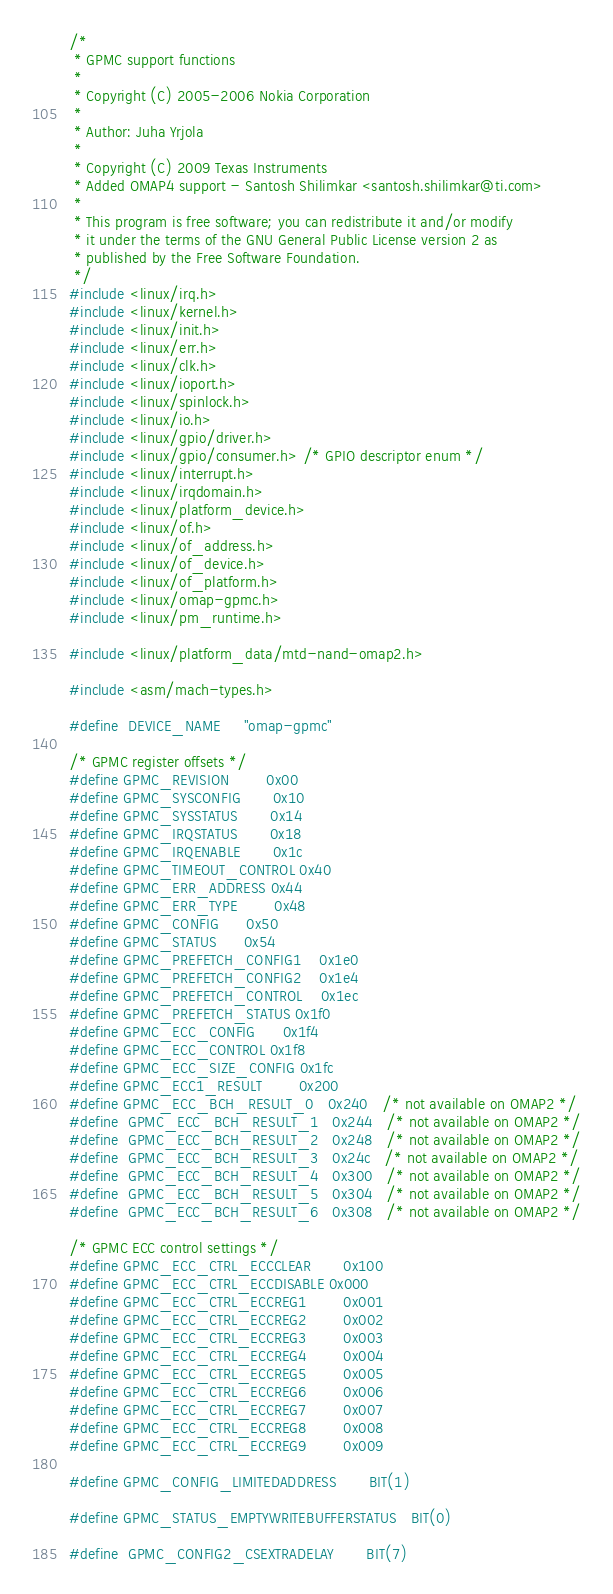Convert code to text. <code><loc_0><loc_0><loc_500><loc_500><_C_>/*
 * GPMC support functions
 *
 * Copyright (C) 2005-2006 Nokia Corporation
 *
 * Author: Juha Yrjola
 *
 * Copyright (C) 2009 Texas Instruments
 * Added OMAP4 support - Santosh Shilimkar <santosh.shilimkar@ti.com>
 *
 * This program is free software; you can redistribute it and/or modify
 * it under the terms of the GNU General Public License version 2 as
 * published by the Free Software Foundation.
 */
#include <linux/irq.h>
#include <linux/kernel.h>
#include <linux/init.h>
#include <linux/err.h>
#include <linux/clk.h>
#include <linux/ioport.h>
#include <linux/spinlock.h>
#include <linux/io.h>
#include <linux/gpio/driver.h>
#include <linux/gpio/consumer.h> /* GPIO descriptor enum */
#include <linux/interrupt.h>
#include <linux/irqdomain.h>
#include <linux/platform_device.h>
#include <linux/of.h>
#include <linux/of_address.h>
#include <linux/of_device.h>
#include <linux/of_platform.h>
#include <linux/omap-gpmc.h>
#include <linux/pm_runtime.h>

#include <linux/platform_data/mtd-nand-omap2.h>

#include <asm/mach-types.h>

#define	DEVICE_NAME		"omap-gpmc"

/* GPMC register offsets */
#define GPMC_REVISION		0x00
#define GPMC_SYSCONFIG		0x10
#define GPMC_SYSSTATUS		0x14
#define GPMC_IRQSTATUS		0x18
#define GPMC_IRQENABLE		0x1c
#define GPMC_TIMEOUT_CONTROL	0x40
#define GPMC_ERR_ADDRESS	0x44
#define GPMC_ERR_TYPE		0x48
#define GPMC_CONFIG		0x50
#define GPMC_STATUS		0x54
#define GPMC_PREFETCH_CONFIG1	0x1e0
#define GPMC_PREFETCH_CONFIG2	0x1e4
#define GPMC_PREFETCH_CONTROL	0x1ec
#define GPMC_PREFETCH_STATUS	0x1f0
#define GPMC_ECC_CONFIG		0x1f4
#define GPMC_ECC_CONTROL	0x1f8
#define GPMC_ECC_SIZE_CONFIG	0x1fc
#define GPMC_ECC1_RESULT        0x200
#define GPMC_ECC_BCH_RESULT_0   0x240   /* not available on OMAP2 */
#define	GPMC_ECC_BCH_RESULT_1	0x244	/* not available on OMAP2 */
#define	GPMC_ECC_BCH_RESULT_2	0x248	/* not available on OMAP2 */
#define	GPMC_ECC_BCH_RESULT_3	0x24c	/* not available on OMAP2 */
#define	GPMC_ECC_BCH_RESULT_4	0x300	/* not available on OMAP2 */
#define	GPMC_ECC_BCH_RESULT_5	0x304	/* not available on OMAP2 */
#define	GPMC_ECC_BCH_RESULT_6	0x308	/* not available on OMAP2 */

/* GPMC ECC control settings */
#define GPMC_ECC_CTRL_ECCCLEAR		0x100
#define GPMC_ECC_CTRL_ECCDISABLE	0x000
#define GPMC_ECC_CTRL_ECCREG1		0x001
#define GPMC_ECC_CTRL_ECCREG2		0x002
#define GPMC_ECC_CTRL_ECCREG3		0x003
#define GPMC_ECC_CTRL_ECCREG4		0x004
#define GPMC_ECC_CTRL_ECCREG5		0x005
#define GPMC_ECC_CTRL_ECCREG6		0x006
#define GPMC_ECC_CTRL_ECCREG7		0x007
#define GPMC_ECC_CTRL_ECCREG8		0x008
#define GPMC_ECC_CTRL_ECCREG9		0x009

#define GPMC_CONFIG_LIMITEDADDRESS		BIT(1)

#define GPMC_STATUS_EMPTYWRITEBUFFERSTATUS	BIT(0)

#define	GPMC_CONFIG2_CSEXTRADELAY		BIT(7)</code> 